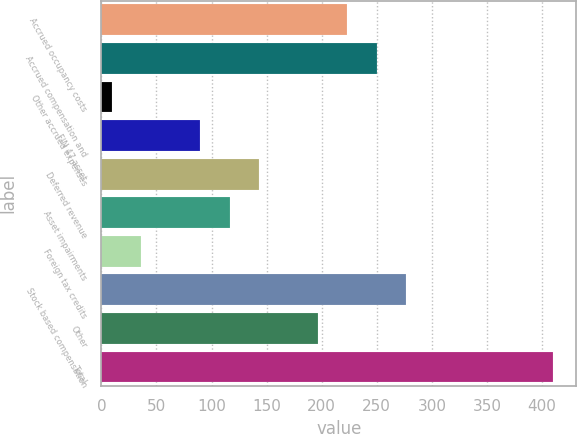Convert chart. <chart><loc_0><loc_0><loc_500><loc_500><bar_chart><fcel>Accrued occupancy costs<fcel>Accrued compensation and<fcel>Other accrued expenses<fcel>FIN 47 asset<fcel>Deferred revenue<fcel>Asset impairments<fcel>Foreign tax credits<fcel>Stock based compensation<fcel>Other<fcel>Total<nl><fcel>223.24<fcel>249.97<fcel>9.4<fcel>89.59<fcel>143.05<fcel>116.32<fcel>36.13<fcel>276.7<fcel>196.51<fcel>410.35<nl></chart> 